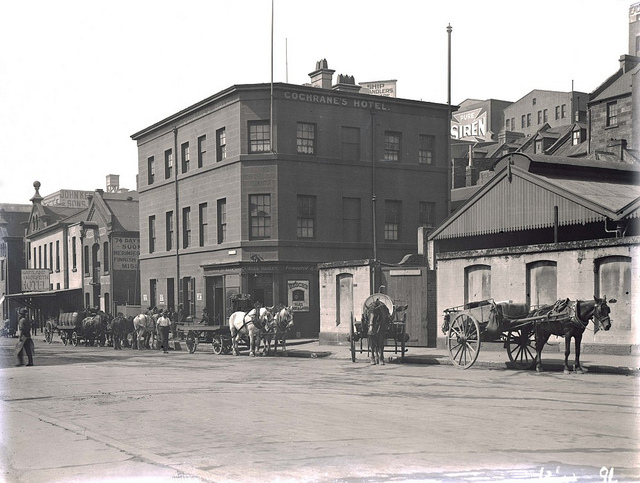<image>What century was this picture taken in? I don't know in which century this picture was taken. It could be either the 18th or 19th century. What century was this picture taken in? I don't know in what century this picture was taken. It can be seen in the 18th or 19th century. 